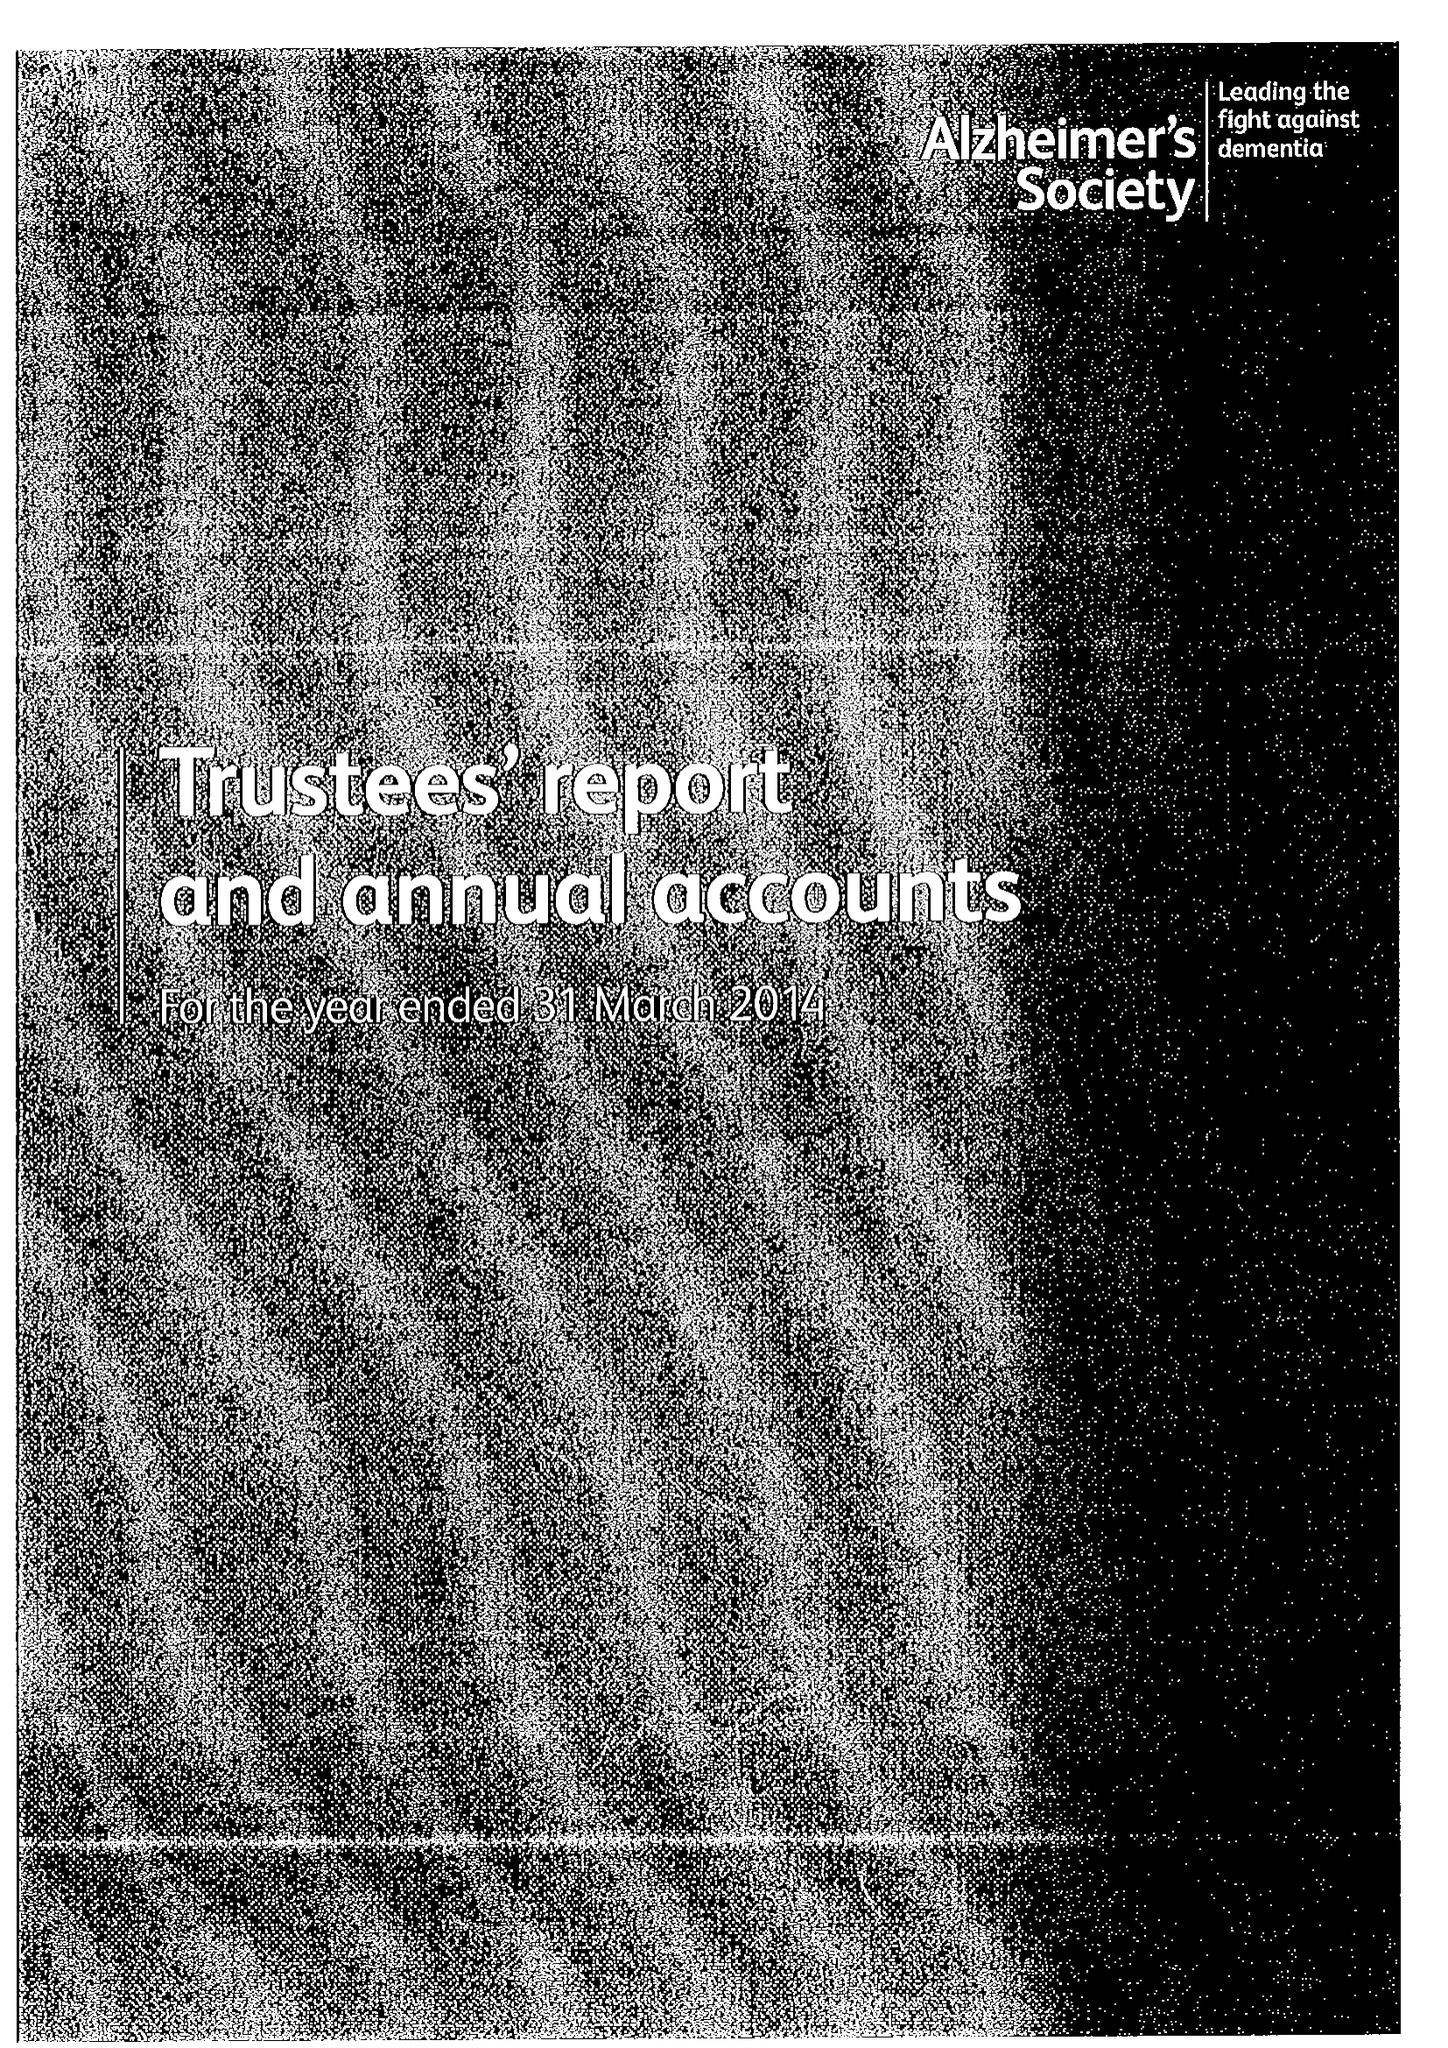What is the value for the income_annually_in_british_pounds?
Answer the question using a single word or phrase. 84437000.00 